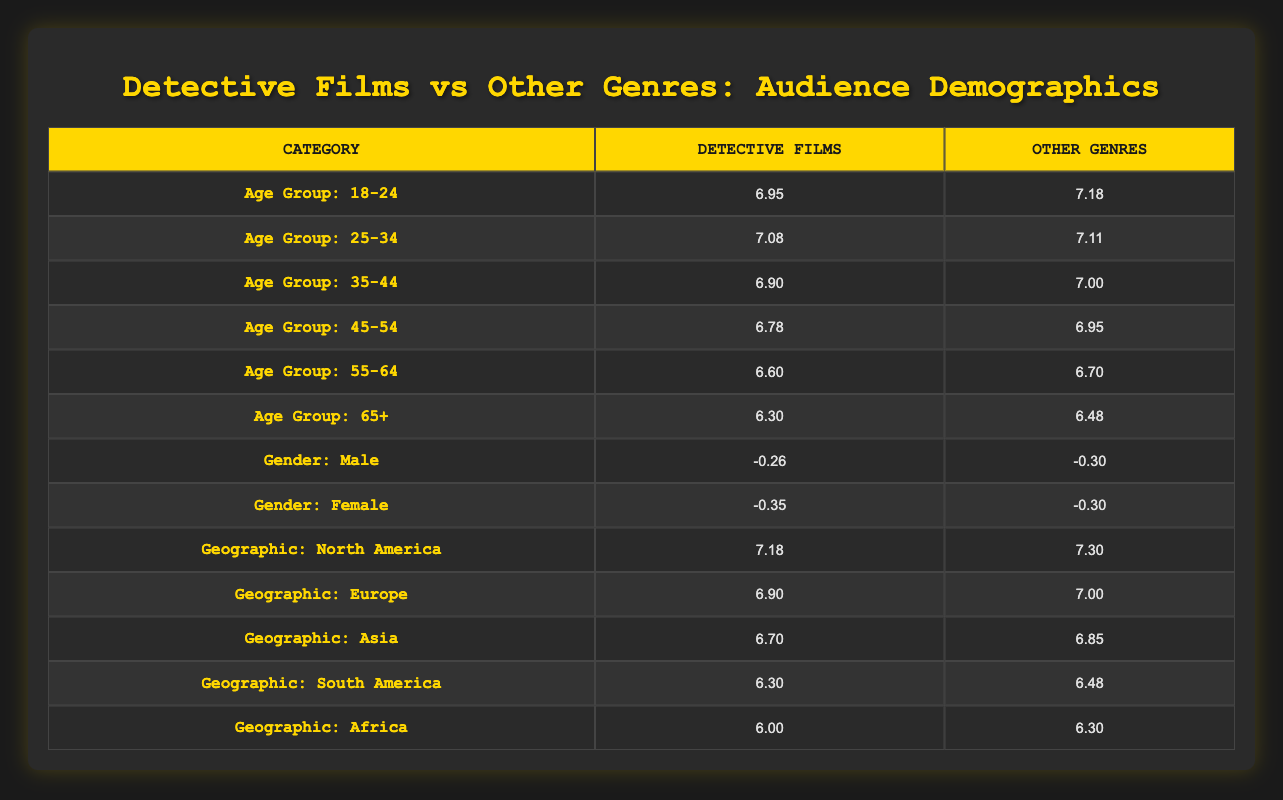What is the logarithmic value for the age group 18-24 for detective films? The logarithmic value for the age group 18-24 for detective films is provided directly in the table under the corresponding row: it is 6.95.
Answer: 6.95 Which age group has the highest logarithmic value for other genres? By reviewing the age groups for other genres in the table, the highest logarithmic value is found in the age group 18-24, which is 7.18.
Answer: 7.18 What is the difference in the logarithmic values for the age group 35-44 between detective films and other genres? The logarithmic value for the age group 35-44 for detective films is 6.90, while for other genres it is 7.00. To find the difference, subtract: 7.00 - 6.90 = 0.10.
Answer: 0.10 Is the gender distribution equally represented in detective films? The table shows that the male gender distribution value is 0.55 and the female is 0.45, indicating unequal representation since they are not equal.
Answer: No What is the average logarithmic value for the age groups of detective films? The logarithmic values for the age groups of detective films are 6.95, 7.08, 6.90, 6.78, 6.60, and 6.30. To find the average, sum these values: (6.95 + 7.08 + 6.90 + 6.78 + 6.60 + 6.30) = 40.59, and then divide by 6: 40.59 / 6 = approximately 6.76.
Answer: 6.76 Which geographic area has the lowest logarithmic value for detective films? The table indicates that the geographic area with the lowest logarithmic value for detective films is Africa, with a value of 6.00.
Answer: 6.00 Explain whether there are more male or female viewers for detective films according to the table. The table shows the male value at -0.26 and the female value at -0.35. Since a higher numeric value (less negative) indicates a larger audience, male viewers are slightly more represented than female viewers, making it true that there are more male viewers.
Answer: Yes What is the total logarithmic value for the geographic distribution of detective films in North America and Europe? From the table, the logarithmic values for North America and Europe are 7.18 and 6.90 respectively. To get the total, add them together: 7.18 + 6.90 = 14.08.
Answer: 14.08 